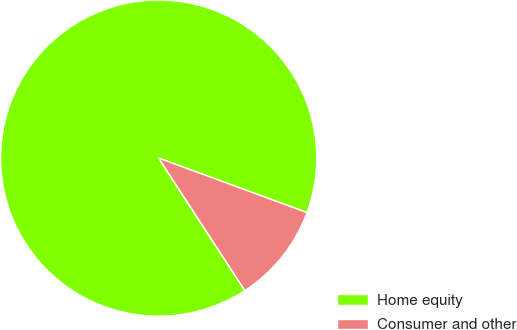Convert chart. <chart><loc_0><loc_0><loc_500><loc_500><pie_chart><fcel>Home equity<fcel>Consumer and other<nl><fcel>89.79%<fcel>10.21%<nl></chart> 